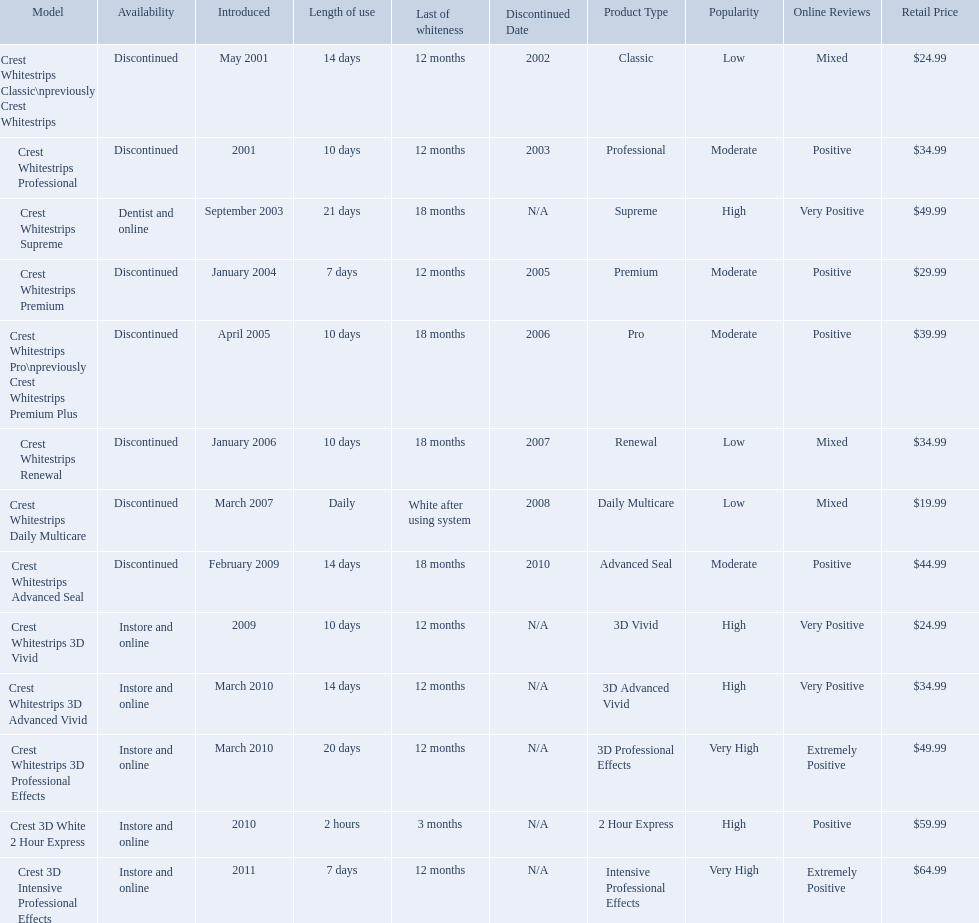Could you parse the entire table? {'header': ['Model', 'Availability', 'Introduced', 'Length of use', 'Last of whiteness', 'Discontinued Date', 'Product Type', 'Popularity', 'Online Reviews', 'Retail Price'], 'rows': [['Crest Whitestrips Classic\\npreviously Crest Whitestrips', 'Discontinued', 'May 2001', '14 days', '12 months', '2002', 'Classic', 'Low', 'Mixed', '$24.99'], ['Crest Whitestrips Professional', 'Discontinued', '2001', '10 days', '12 months', '2003', 'Professional', 'Moderate', 'Positive', '$34.99'], ['Crest Whitestrips Supreme', 'Dentist and online', 'September 2003', '21 days', '18 months', 'N/A', 'Supreme', 'High', 'Very Positive', '$49.99'], ['Crest Whitestrips Premium', 'Discontinued', 'January 2004', '7 days', '12 months', '2005', 'Premium', 'Moderate', 'Positive', '$29.99'], ['Crest Whitestrips Pro\\npreviously Crest Whitestrips Premium Plus', 'Discontinued', 'April 2005', '10 days', '18 months', '2006', 'Pro', 'Moderate', 'Positive', '$39.99'], ['Crest Whitestrips Renewal', 'Discontinued', 'January 2006', '10 days', '18 months', '2007', 'Renewal', 'Low', 'Mixed', '$34.99'], ['Crest Whitestrips Daily Multicare', 'Discontinued', 'March 2007', 'Daily', 'White after using system', '2008', 'Daily Multicare', 'Low', 'Mixed', '$19.99'], ['Crest Whitestrips Advanced Seal', 'Discontinued', 'February 2009', '14 days', '18 months', '2010', 'Advanced Seal', 'Moderate', 'Positive', '$44.99'], ['Crest Whitestrips 3D Vivid', 'Instore and online', '2009', '10 days', '12 months', 'N/A', '3D Vivid', 'High', 'Very Positive', '$24.99'], ['Crest Whitestrips 3D Advanced Vivid', 'Instore and online', 'March 2010', '14 days', '12 months', 'N/A', '3D Advanced Vivid', 'High', 'Very Positive', '$34.99'], ['Crest Whitestrips 3D Professional Effects', 'Instore and online', 'March 2010', '20 days', '12 months', 'N/A', '3D Professional Effects', 'Very High', 'Extremely Positive', '$49.99'], ['Crest 3D White 2 Hour Express', 'Instore and online', '2010', '2 hours', '3 months', 'N/A', '2 Hour Express', 'High', 'Positive', '$59.99'], ['Crest 3D Intensive Professional Effects', 'Instore and online', '2011', '7 days', '12 months', 'N/A', 'Intensive Professional Effects', 'Very High', 'Extremely Positive', '$64.99']]} What types of crest whitestrips have been released? Crest Whitestrips Classic\npreviously Crest Whitestrips, Crest Whitestrips Professional, Crest Whitestrips Supreme, Crest Whitestrips Premium, Crest Whitestrips Pro\npreviously Crest Whitestrips Premium Plus, Crest Whitestrips Renewal, Crest Whitestrips Daily Multicare, Crest Whitestrips Advanced Seal, Crest Whitestrips 3D Vivid, Crest Whitestrips 3D Advanced Vivid, Crest Whitestrips 3D Professional Effects, Crest 3D White 2 Hour Express, Crest 3D Intensive Professional Effects. What was the length of use for each type? 14 days, 10 days, 21 days, 7 days, 10 days, 10 days, Daily, 14 days, 10 days, 14 days, 20 days, 2 hours, 7 days. And how long did each last? 12 months, 12 months, 18 months, 12 months, 18 months, 18 months, White after using system, 18 months, 12 months, 12 months, 12 months, 3 months, 12 months. Of those models, which lasted the longest with the longest length of use? Crest Whitestrips Supreme. Which models are still available? Crest Whitestrips Supreme, Crest Whitestrips 3D Vivid, Crest Whitestrips 3D Advanced Vivid, Crest Whitestrips 3D Professional Effects, Crest 3D White 2 Hour Express, Crest 3D Intensive Professional Effects. Would you be able to parse every entry in this table? {'header': ['Model', 'Availability', 'Introduced', 'Length of use', 'Last of whiteness', 'Discontinued Date', 'Product Type', 'Popularity', 'Online Reviews', 'Retail Price'], 'rows': [['Crest Whitestrips Classic\\npreviously Crest Whitestrips', 'Discontinued', 'May 2001', '14 days', '12 months', '2002', 'Classic', 'Low', 'Mixed', '$24.99'], ['Crest Whitestrips Professional', 'Discontinued', '2001', '10 days', '12 months', '2003', 'Professional', 'Moderate', 'Positive', '$34.99'], ['Crest Whitestrips Supreme', 'Dentist and online', 'September 2003', '21 days', '18 months', 'N/A', 'Supreme', 'High', 'Very Positive', '$49.99'], ['Crest Whitestrips Premium', 'Discontinued', 'January 2004', '7 days', '12 months', '2005', 'Premium', 'Moderate', 'Positive', '$29.99'], ['Crest Whitestrips Pro\\npreviously Crest Whitestrips Premium Plus', 'Discontinued', 'April 2005', '10 days', '18 months', '2006', 'Pro', 'Moderate', 'Positive', '$39.99'], ['Crest Whitestrips Renewal', 'Discontinued', 'January 2006', '10 days', '18 months', '2007', 'Renewal', 'Low', 'Mixed', '$34.99'], ['Crest Whitestrips Daily Multicare', 'Discontinued', 'March 2007', 'Daily', 'White after using system', '2008', 'Daily Multicare', 'Low', 'Mixed', '$19.99'], ['Crest Whitestrips Advanced Seal', 'Discontinued', 'February 2009', '14 days', '18 months', '2010', 'Advanced Seal', 'Moderate', 'Positive', '$44.99'], ['Crest Whitestrips 3D Vivid', 'Instore and online', '2009', '10 days', '12 months', 'N/A', '3D Vivid', 'High', 'Very Positive', '$24.99'], ['Crest Whitestrips 3D Advanced Vivid', 'Instore and online', 'March 2010', '14 days', '12 months', 'N/A', '3D Advanced Vivid', 'High', 'Very Positive', '$34.99'], ['Crest Whitestrips 3D Professional Effects', 'Instore and online', 'March 2010', '20 days', '12 months', 'N/A', '3D Professional Effects', 'Very High', 'Extremely Positive', '$49.99'], ['Crest 3D White 2 Hour Express', 'Instore and online', '2010', '2 hours', '3 months', 'N/A', '2 Hour Express', 'High', 'Positive', '$59.99'], ['Crest 3D Intensive Professional Effects', 'Instore and online', '2011', '7 days', '12 months', 'N/A', 'Intensive Professional Effects', 'Very High', 'Extremely Positive', '$64.99']]} Of those, which were introduced prior to 2011? Crest Whitestrips Supreme, Crest Whitestrips 3D Vivid, Crest Whitestrips 3D Advanced Vivid, Crest Whitestrips 3D Professional Effects, Crest 3D White 2 Hour Express. Among those models, which ones had to be used at least 14 days? Crest Whitestrips Supreme, Crest Whitestrips 3D Advanced Vivid, Crest Whitestrips 3D Professional Effects. Which of those lasted longer than 12 months? Crest Whitestrips Supreme. What are all of the model names? Crest Whitestrips Classic\npreviously Crest Whitestrips, Crest Whitestrips Professional, Crest Whitestrips Supreme, Crest Whitestrips Premium, Crest Whitestrips Pro\npreviously Crest Whitestrips Premium Plus, Crest Whitestrips Renewal, Crest Whitestrips Daily Multicare, Crest Whitestrips Advanced Seal, Crest Whitestrips 3D Vivid, Crest Whitestrips 3D Advanced Vivid, Crest Whitestrips 3D Professional Effects, Crest 3D White 2 Hour Express, Crest 3D Intensive Professional Effects. When were they first introduced? May 2001, 2001, September 2003, January 2004, April 2005, January 2006, March 2007, February 2009, 2009, March 2010, March 2010, 2010, 2011. Along with crest whitestrips 3d advanced vivid, which other model was introduced in march 2010? Crest Whitestrips 3D Professional Effects. What year did crest come out with crest white strips 3d vivid? 2009. Which crest product was also introduced he same year, but is now discontinued? Crest Whitestrips Advanced Seal. 